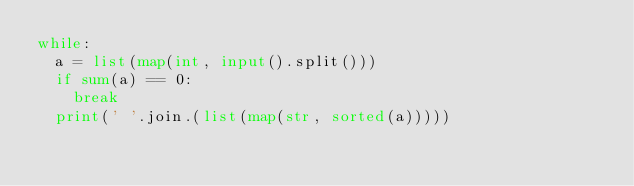<code> <loc_0><loc_0><loc_500><loc_500><_Python_>while:
  a = list(map(int, input().split()))
  if sum(a) == 0:
    break
  print(' '.join.(list(map(str, sorted(a)))))</code> 